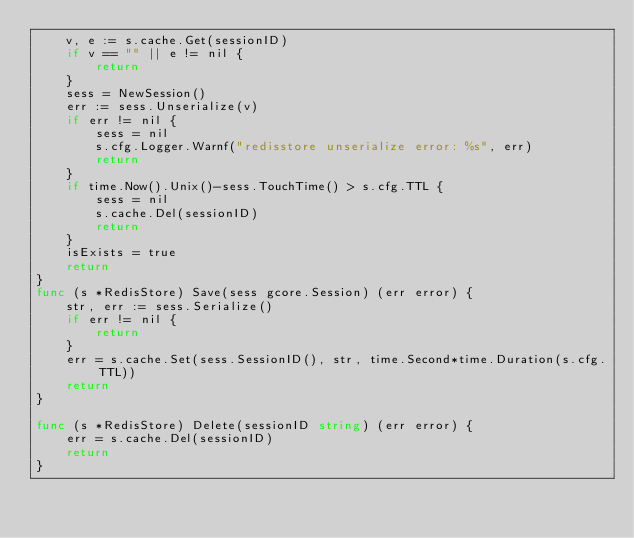Convert code to text. <code><loc_0><loc_0><loc_500><loc_500><_Go_>	v, e := s.cache.Get(sessionID)
	if v == "" || e != nil {
		return
	}
	sess = NewSession()
	err := sess.Unserialize(v)
	if err != nil {
		sess = nil
		s.cfg.Logger.Warnf("redisstore unserialize error: %s", err)
		return
	}
	if time.Now().Unix()-sess.TouchTime() > s.cfg.TTL {
		sess = nil
		s.cache.Del(sessionID)
		return
	}
	isExists = true
	return
}
func (s *RedisStore) Save(sess gcore.Session) (err error) {
	str, err := sess.Serialize()
	if err != nil {
		return
	}
	err = s.cache.Set(sess.SessionID(), str, time.Second*time.Duration(s.cfg.TTL))
	return
}

func (s *RedisStore) Delete(sessionID string) (err error) {
	err = s.cache.Del(sessionID)
	return
}
</code> 